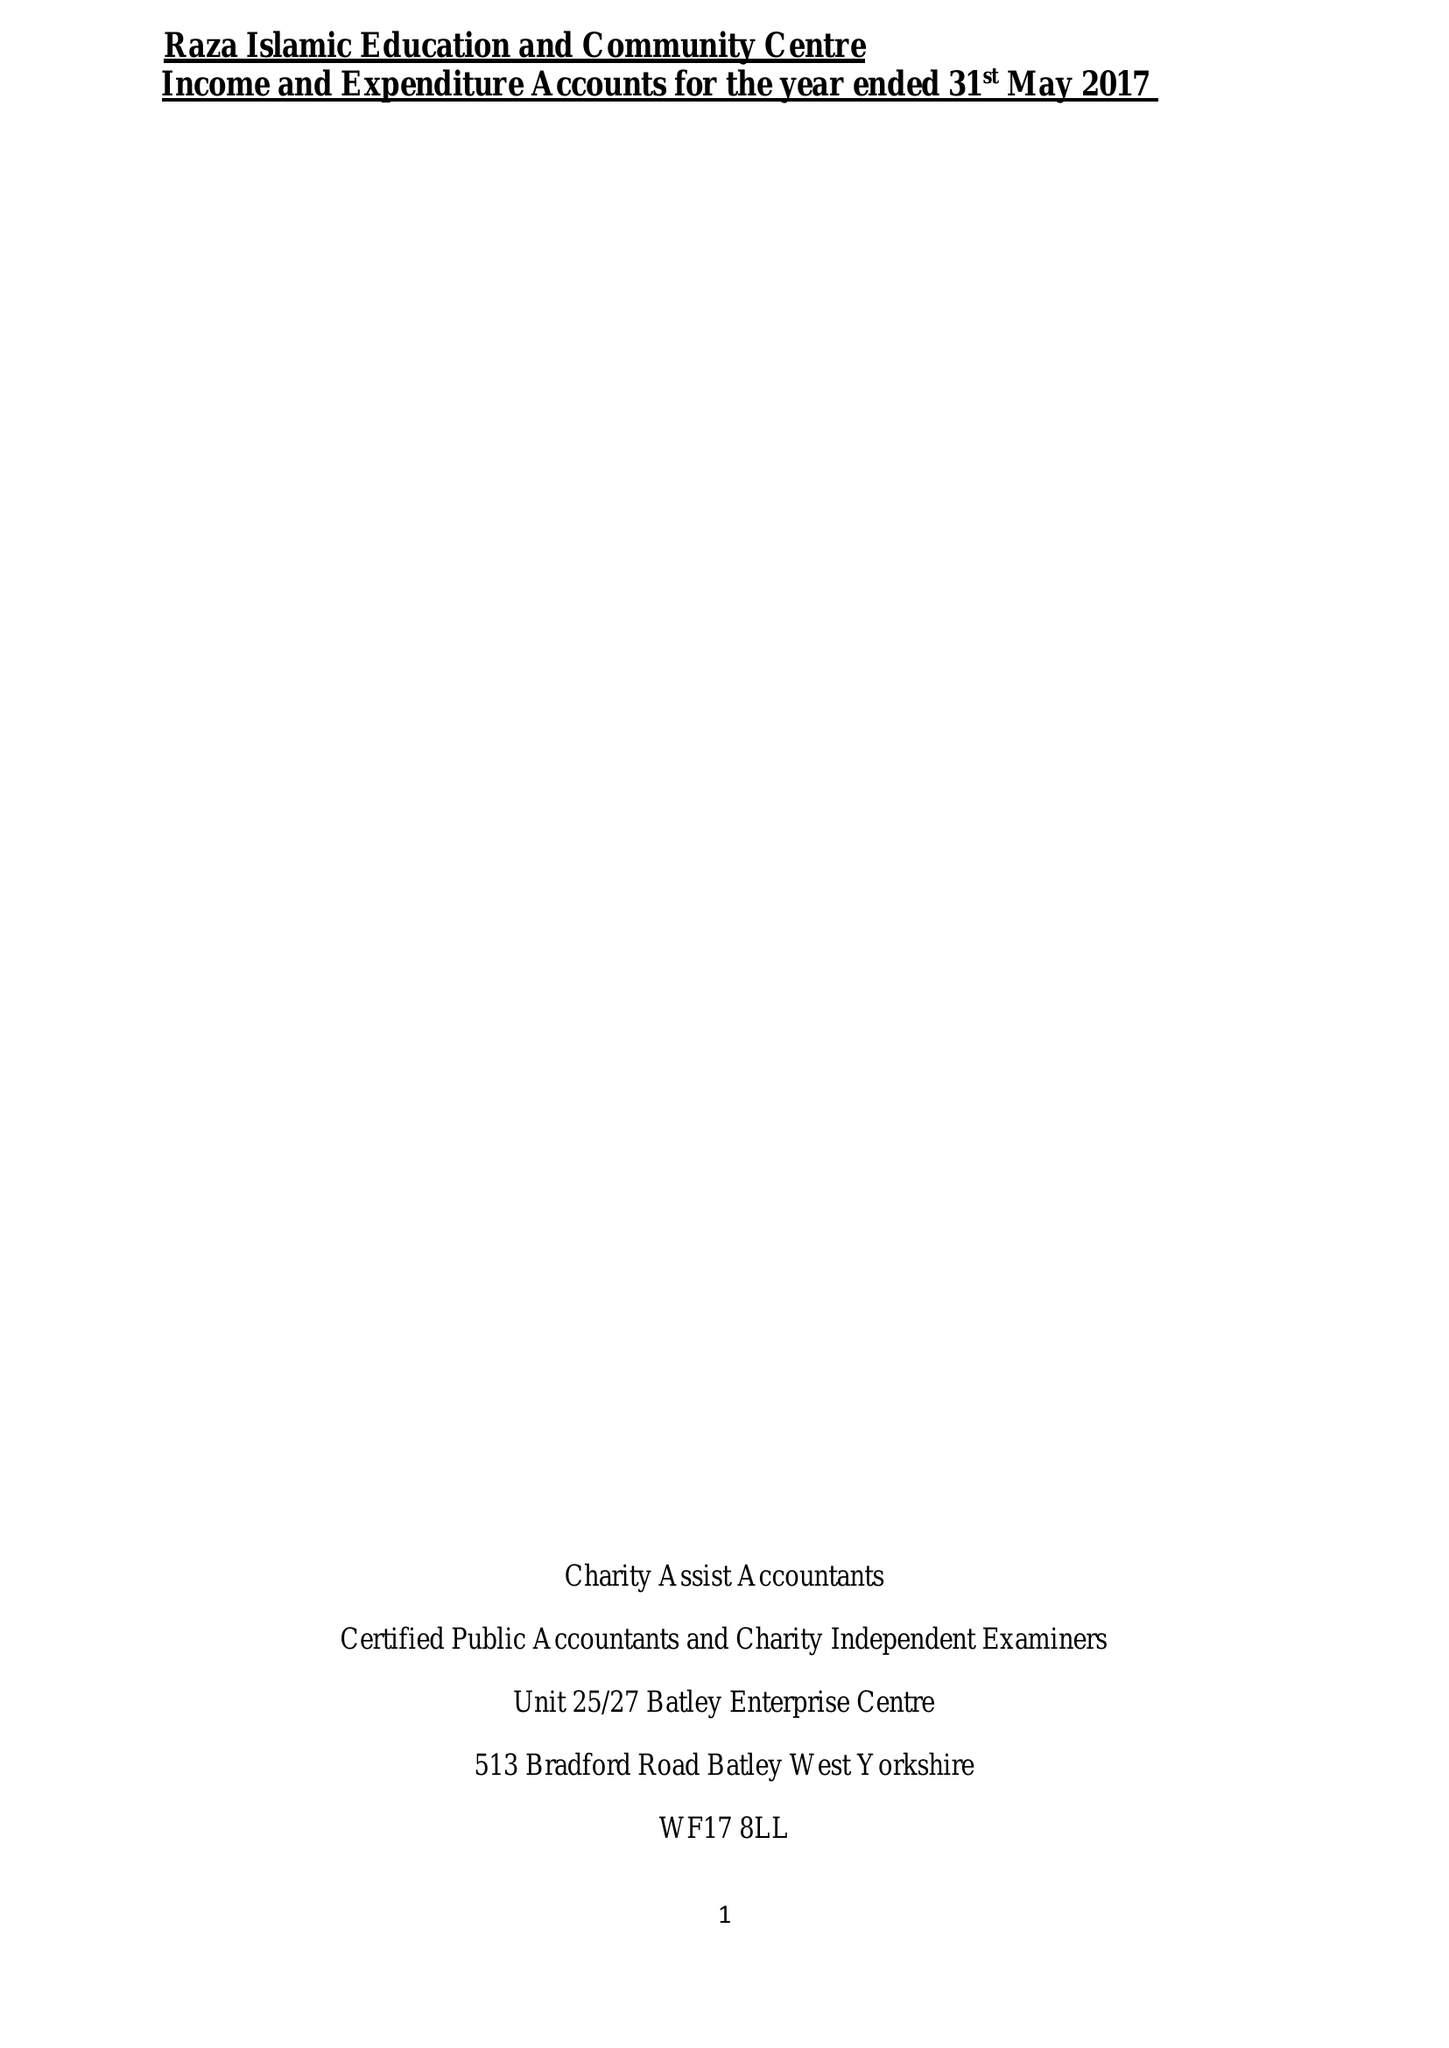What is the value for the spending_annually_in_british_pounds?
Answer the question using a single word or phrase. 73880.00 